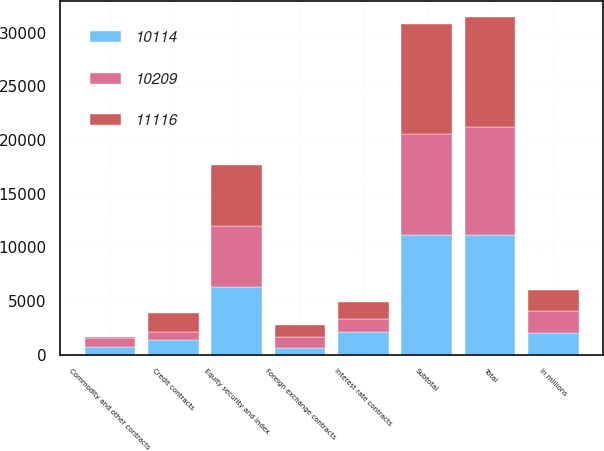Convert chart to OTSL. <chart><loc_0><loc_0><loc_500><loc_500><stacked_bar_chart><ecel><fcel>in millions<fcel>Interest rate contracts<fcel>Foreign exchange contracts<fcel>Equity security and index<fcel>Commodity and other contracts<fcel>Credit contracts<fcel>Subtotal<fcel>Total<nl><fcel>10114<fcel>2017<fcel>2091<fcel>647<fcel>6291<fcel>740<fcel>1347<fcel>11116<fcel>11116<nl><fcel>11116<fcel>2016<fcel>1522<fcel>1156<fcel>5690<fcel>56<fcel>1785<fcel>10209<fcel>10209<nl><fcel>10209<fcel>2015<fcel>1249<fcel>984<fcel>5695<fcel>793<fcel>775<fcel>9496<fcel>10114<nl></chart> 